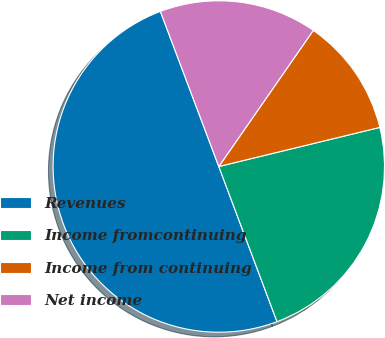<chart> <loc_0><loc_0><loc_500><loc_500><pie_chart><fcel>Revenues<fcel>Income fromcontinuing<fcel>Income from continuing<fcel>Net income<nl><fcel>49.98%<fcel>23.08%<fcel>11.55%<fcel>15.39%<nl></chart> 